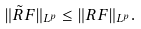Convert formula to latex. <formula><loc_0><loc_0><loc_500><loc_500>\| \tilde { R } F \| _ { L ^ { p } } \leq \| R F \| _ { L ^ { p } } .</formula> 